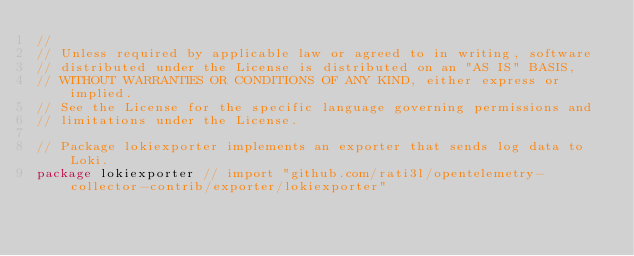<code> <loc_0><loc_0><loc_500><loc_500><_Go_>//
// Unless required by applicable law or agreed to in writing, software
// distributed under the License is distributed on an "AS IS" BASIS,
// WITHOUT WARRANTIES OR CONDITIONS OF ANY KIND, either express or implied.
// See the License for the specific language governing permissions and
// limitations under the License.

// Package lokiexporter implements an exporter that sends log data to Loki.
package lokiexporter // import "github.com/rati3l/opentelemetry-collector-contrib/exporter/lokiexporter"
</code> 